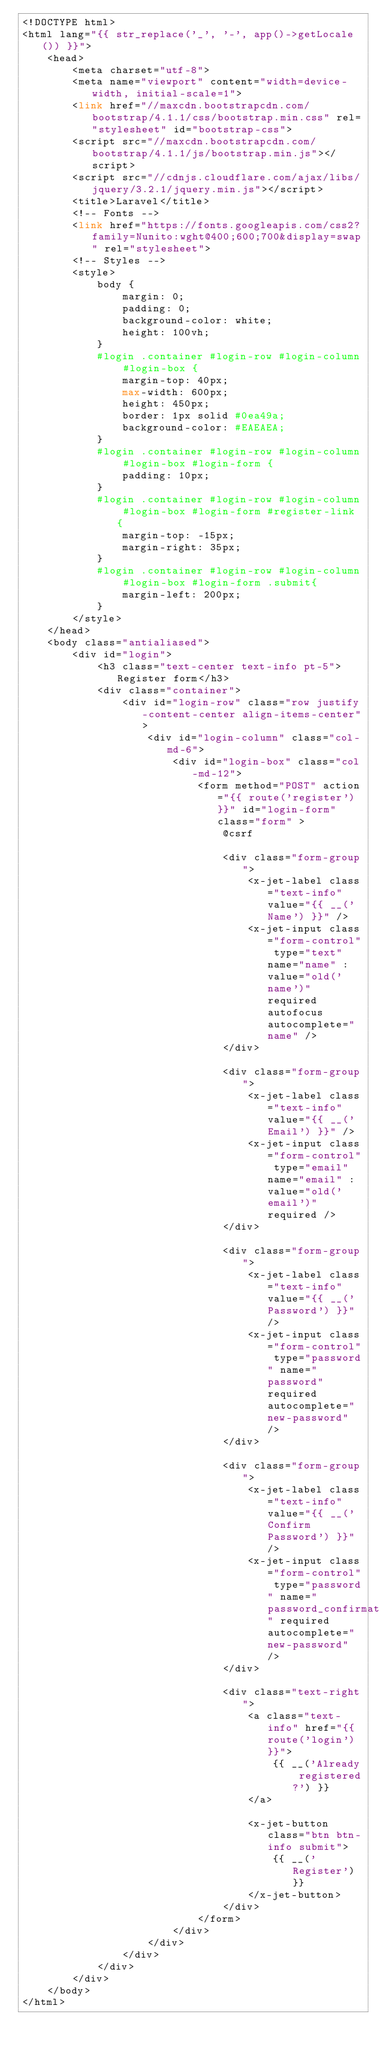<code> <loc_0><loc_0><loc_500><loc_500><_PHP_><!DOCTYPE html>
<html lang="{{ str_replace('_', '-', app()->getLocale()) }}">
    <head>
        <meta charset="utf-8">
        <meta name="viewport" content="width=device-width, initial-scale=1">
        <link href="//maxcdn.bootstrapcdn.com/bootstrap/4.1.1/css/bootstrap.min.css" rel="stylesheet" id="bootstrap-css">
        <script src="//maxcdn.bootstrapcdn.com/bootstrap/4.1.1/js/bootstrap.min.js"></script>
        <script src="//cdnjs.cloudflare.com/ajax/libs/jquery/3.2.1/jquery.min.js"></script>
        <title>Laravel</title>
        <!-- Fonts -->
        <link href="https://fonts.googleapis.com/css2?family=Nunito:wght@400;600;700&display=swap" rel="stylesheet">
        <!-- Styles -->
        <style>
            body {
                margin: 0;
                padding: 0;
                background-color: white;
                height: 100vh;
            }
            #login .container #login-row #login-column #login-box {
                margin-top: 40px;
                max-width: 600px;
                height: 450px;
                border: 1px solid #0ea49a;
                background-color: #EAEAEA;
            }
            #login .container #login-row #login-column #login-box #login-form {
                padding: 10px;
            }
            #login .container #login-row #login-column #login-box #login-form #register-link {
                margin-top: -15px;
                margin-right: 35px;
            }
            #login .container #login-row #login-column #login-box #login-form .submit{
                margin-left: 200px;
            }
        </style>
    </head>
    <body class="antialiased">
        <div id="login">
            <h3 class="text-center text-info pt-5">Register form</h3>
            <div class="container">
                <div id="login-row" class="row justify-content-center align-items-center">
                    <div id="login-column" class="col-md-6">
                        <div id="login-box" class="col-md-12">
                            <form method="POST" action="{{ route('register') }}" id="login-form" class="form" >
                                @csrf

                                <div class="form-group">
                                    <x-jet-label class="text-info" value="{{ __('Name') }}" />
                                    <x-jet-input class="form-control" type="text" name="name" :value="old('name')" required autofocus autocomplete="name" />
                                </div>

                                <div class="form-group">
                                    <x-jet-label class="text-info" value="{{ __('Email') }}" />
                                    <x-jet-input class="form-control" type="email" name="email" :value="old('email')" required />
                                </div>

                                <div class="form-group">
                                    <x-jet-label class="text-info" value="{{ __('Password') }}" />
                                    <x-jet-input class="form-control" type="password" name="password" required autocomplete="new-password" />
                                </div>

                                <div class="form-group">
                                    <x-jet-label class="text-info" value="{{ __('Confirm Password') }}" />
                                    <x-jet-input class="form-control" type="password" name="password_confirmation" required autocomplete="new-password" />
                                </div>

                                <div class="text-right">
                                    <a class="text-info" href="{{ route('login') }}">
                                        {{ __('Already registered?') }}
                                    </a>

                                    <x-jet-button class="btn btn-info submit">
                                        {{ __('Register') }}
                                    </x-jet-button>
                                </div>
                            </form>
                        </div>
                    </div>
                </div>
            </div>
        </div>
    </body>
</html>


</code> 